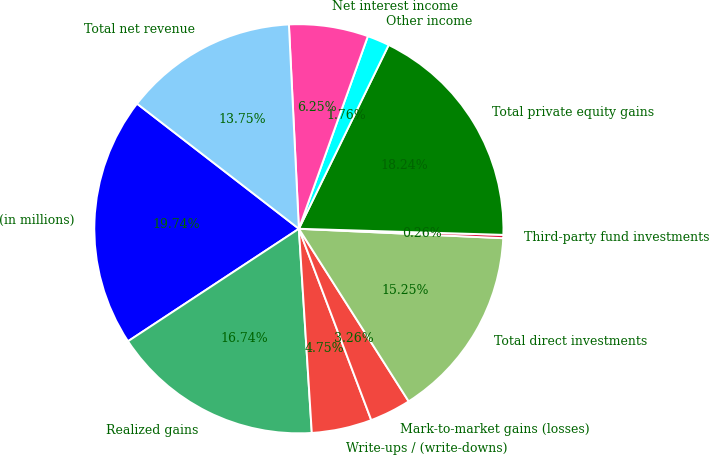<chart> <loc_0><loc_0><loc_500><loc_500><pie_chart><fcel>(in millions)<fcel>Realized gains<fcel>Write-ups / (write-downs)<fcel>Mark-to-market gains (losses)<fcel>Total direct investments<fcel>Third-party fund investments<fcel>Total private equity gains<fcel>Other income<fcel>Net interest income<fcel>Total net revenue<nl><fcel>19.74%<fcel>16.74%<fcel>4.75%<fcel>3.26%<fcel>15.25%<fcel>0.26%<fcel>18.24%<fcel>1.76%<fcel>6.25%<fcel>13.75%<nl></chart> 